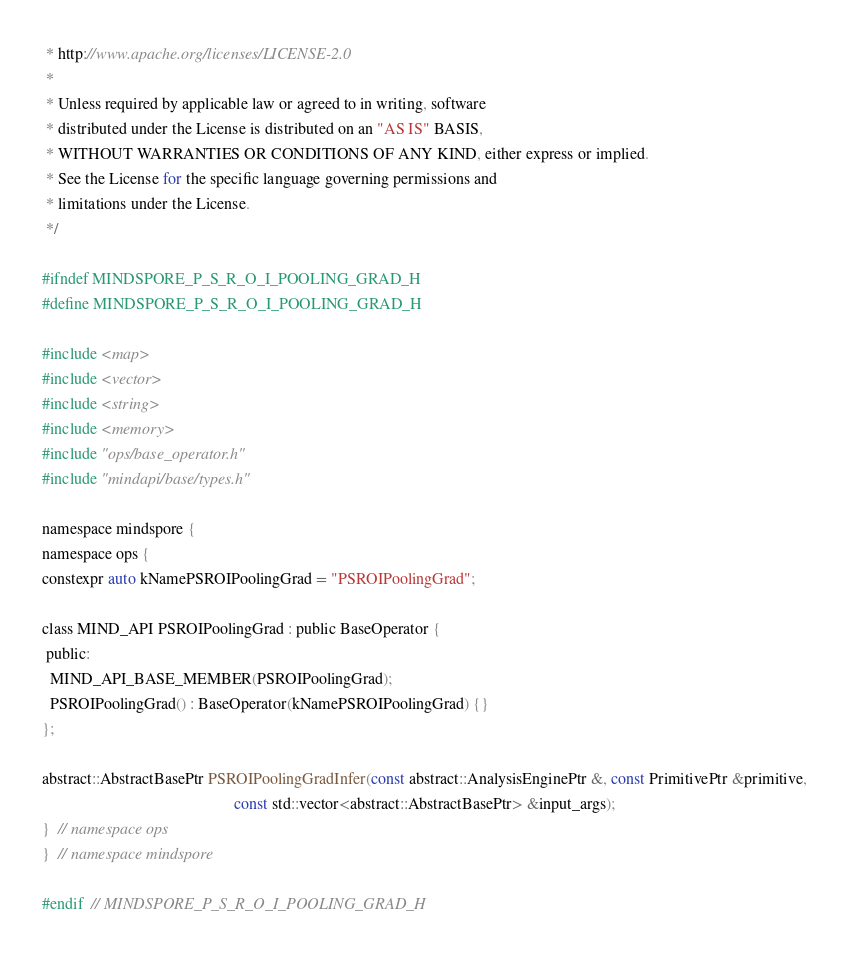<code> <loc_0><loc_0><loc_500><loc_500><_C_> * http://www.apache.org/licenses/LICENSE-2.0
 *
 * Unless required by applicable law or agreed to in writing, software
 * distributed under the License is distributed on an "AS IS" BASIS,
 * WITHOUT WARRANTIES OR CONDITIONS OF ANY KIND, either express or implied.
 * See the License for the specific language governing permissions and
 * limitations under the License.
 */

#ifndef MINDSPORE_P_S_R_O_I_POOLING_GRAD_H
#define MINDSPORE_P_S_R_O_I_POOLING_GRAD_H

#include <map>
#include <vector>
#include <string>
#include <memory>
#include "ops/base_operator.h"
#include "mindapi/base/types.h"

namespace mindspore {
namespace ops {
constexpr auto kNamePSROIPoolingGrad = "PSROIPoolingGrad";

class MIND_API PSROIPoolingGrad : public BaseOperator {
 public:
  MIND_API_BASE_MEMBER(PSROIPoolingGrad);
  PSROIPoolingGrad() : BaseOperator(kNamePSROIPoolingGrad) {}
};

abstract::AbstractBasePtr PSROIPoolingGradInfer(const abstract::AnalysisEnginePtr &, const PrimitivePtr &primitive,
                                                const std::vector<abstract::AbstractBasePtr> &input_args);
}  // namespace ops
}  // namespace mindspore

#endif  // MINDSPORE_P_S_R_O_I_POOLING_GRAD_H
</code> 